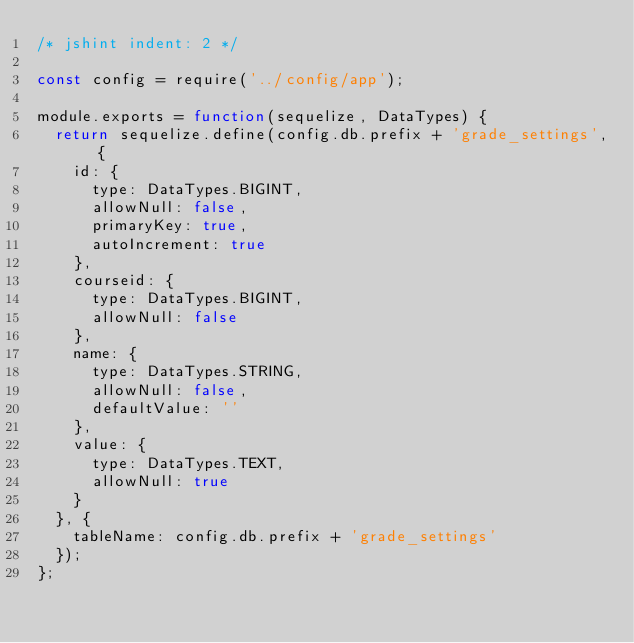Convert code to text. <code><loc_0><loc_0><loc_500><loc_500><_JavaScript_>/* jshint indent: 2 */

const config = require('../config/app');

module.exports = function(sequelize, DataTypes) {
  return sequelize.define(config.db.prefix + 'grade_settings', {
    id: {
      type: DataTypes.BIGINT,
      allowNull: false,
      primaryKey: true,
      autoIncrement: true
    },
    courseid: {
      type: DataTypes.BIGINT,
      allowNull: false
    },
    name: {
      type: DataTypes.STRING,
      allowNull: false,
      defaultValue: ''
    },
    value: {
      type: DataTypes.TEXT,
      allowNull: true
    }
  }, {
    tableName: config.db.prefix + 'grade_settings'
  });
};
</code> 